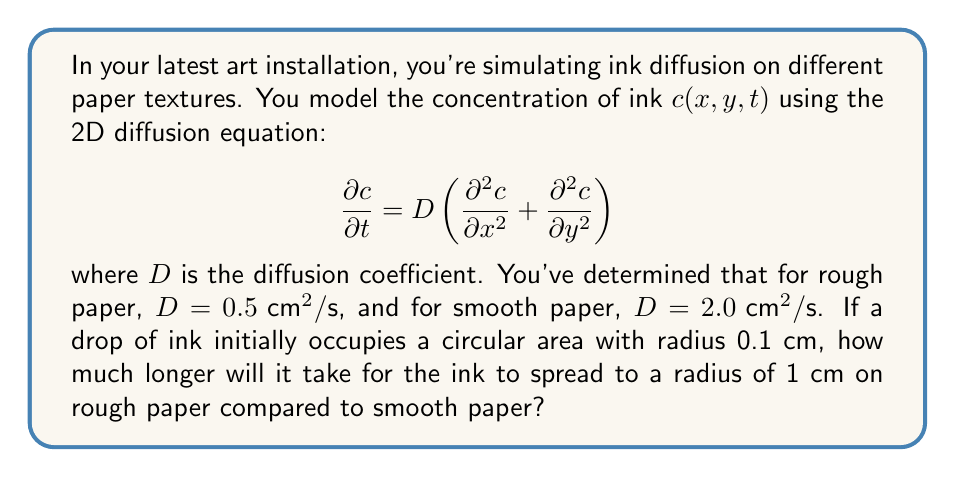Can you answer this question? To solve this problem, we'll use the relationship between diffusion time and distance in the diffusion equation. The characteristic diffusion time $t$ for a substance to spread a distance $r$ is given by:

$$t \approx \frac{r^2}{4D}$$

1) For rough paper:
   $D_1 = 0.5 \text{ cm}^2/\text{s}$
   Initial radius $r_0 = 0.1 \text{ cm}$
   Final radius $r_1 = 1 \text{ cm}$

   Time to spread: $t_1 = \frac{r_1^2 - r_0^2}{4D_1} = \frac{1^2 - 0.1^2}{4(0.5)} = 0.495 \text{ s}$

2) For smooth paper:
   $D_2 = 2.0 \text{ cm}^2/\text{s}$
   Initial and final radii are the same as above.

   Time to spread: $t_2 = \frac{r_1^2 - r_0^2}{4D_2} = \frac{1^2 - 0.1^2}{4(2.0)} = 0.12375 \text{ s}$

3) Difference in time:
   $\Delta t = t_1 - t_2 = 0.495 - 0.12375 = 0.37125 \text{ s}$

Therefore, it will take approximately 0.37125 seconds longer for the ink to spread on rough paper compared to smooth paper.
Answer: 0.37125 s 